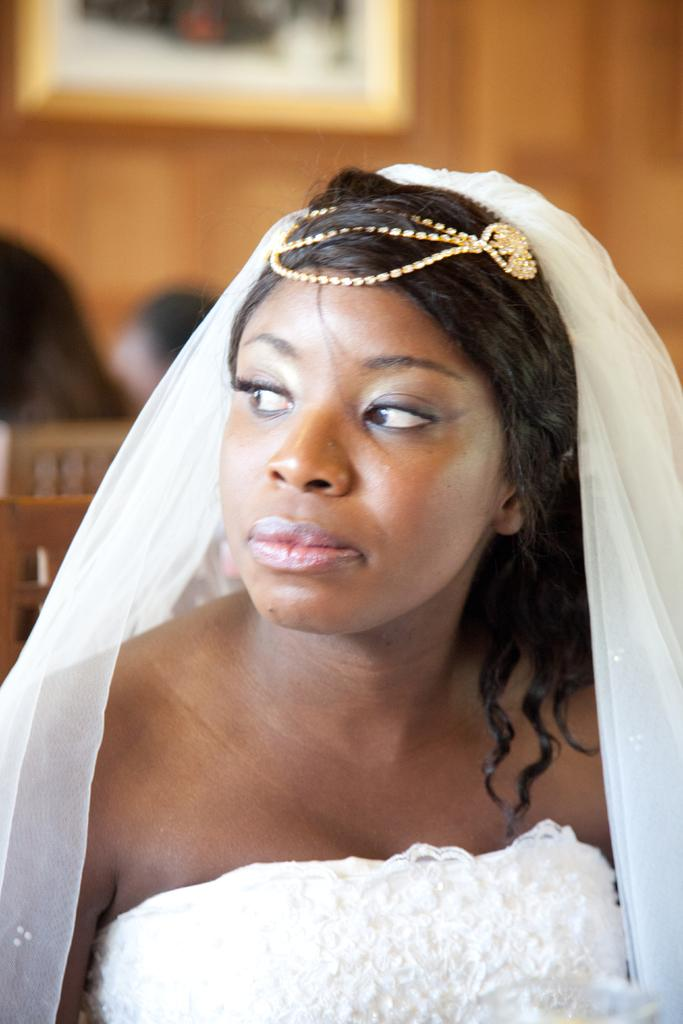Who is present in the image? There is a woman in the image. What is the woman wearing? The woman is wearing a white dress. What can be seen in the background of the image? There is a photo on the wall in the background of the image. Can you tell me how many babies are in the river in the image? There is no river or baby present in the image; it features a woman wearing a white dress with a photo on the wall in the background. 